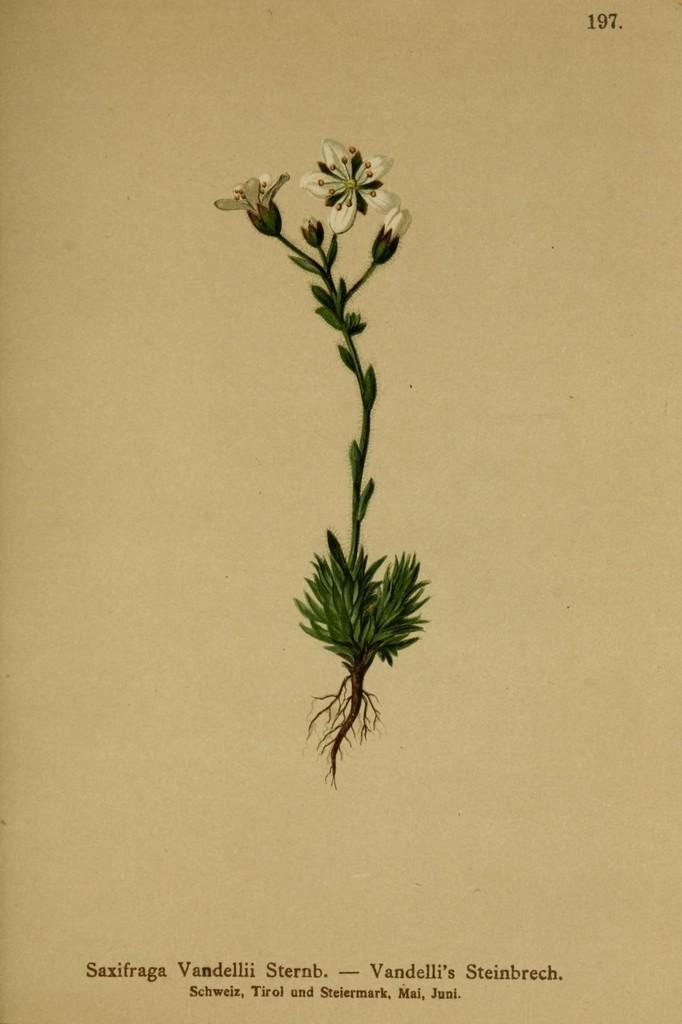Could you give a brief overview of what you see in this image? In this picture we can observe a plant which is on the paper. We can observe white color flowers. The background is in cream color. We can observe some text in this picture. 